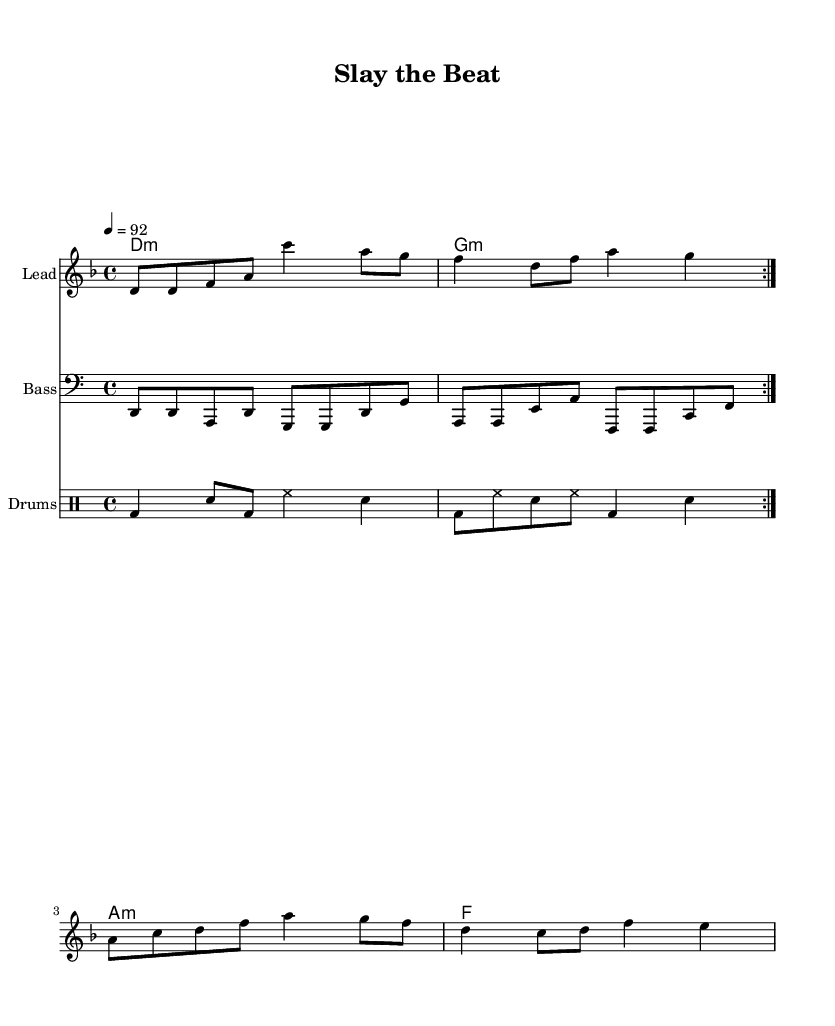What is the key signature of this music? The key signature displayed in the music indicates one flat, which corresponds to D minor.
Answer: D minor What is the time signature of the piece? The time signature is located at the beginning of the score and shows a 4 over 4, indicating common time.
Answer: 4/4 What is the tempo marking for this piece? The tempo marking is noted as "4 = 92," which means there are 92 beats per minute.
Answer: 92 How many measures are in the chorus? By analyzing the lyrics' alignment with the melody, we can see that the chorus consists of four measures.
Answer: 4 What is the primary instrument for the melody in this score? The score indicates that the staff with the melody is labeled as "Lead," which identifies the primary instrument as lead.
Answer: Lead What genre does this piece belong to? Since the piece includes elements commonly found in contemporary music and features drag culture references, it is categorized under Hip Hop.
Answer: Hip Hop What is the last note of the bass line in the repeated section? By examining the bass line written in the score, the last note in the repeated section is G, as indicated in the music notation.
Answer: G 